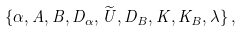<formula> <loc_0><loc_0><loc_500><loc_500>\{ \alpha , A , B , D _ { \alpha } , \widetilde { U } , D _ { B } , K , K _ { B } , \lambda \} \, ,</formula> 